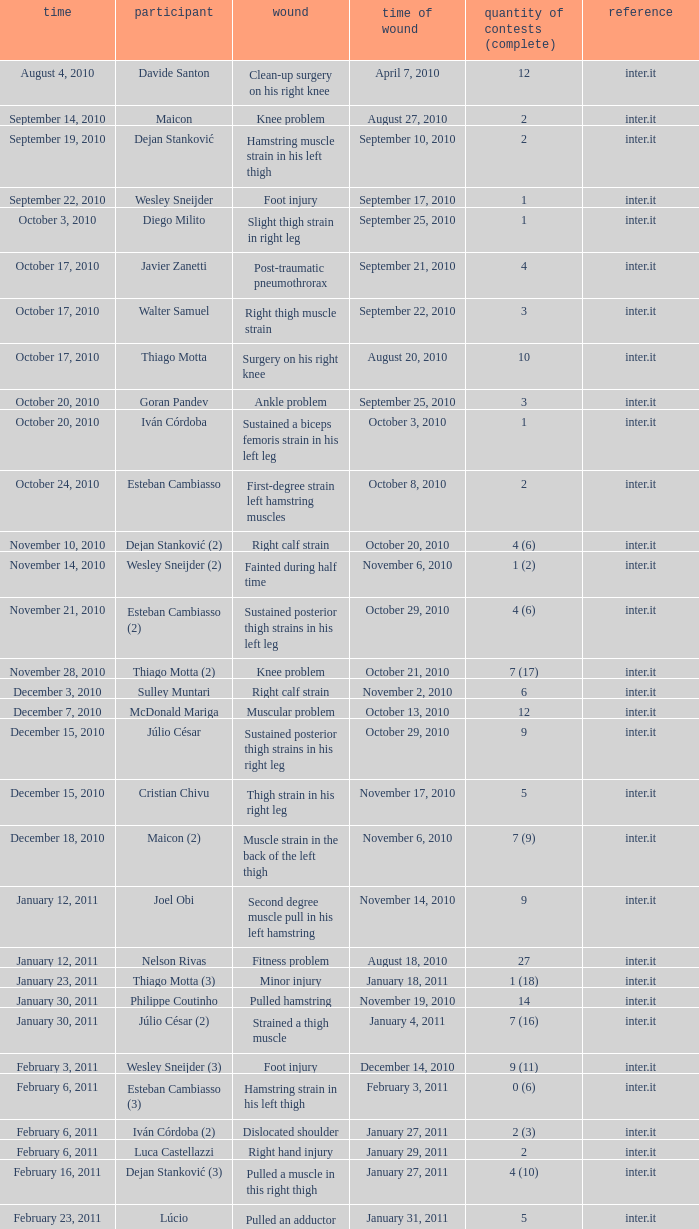Can you parse all the data within this table? {'header': ['time', 'participant', 'wound', 'time of wound', 'quantity of contests (complete)', 'reference'], 'rows': [['August 4, 2010', 'Davide Santon', 'Clean-up surgery on his right knee', 'April 7, 2010', '12', 'inter.it'], ['September 14, 2010', 'Maicon', 'Knee problem', 'August 27, 2010', '2', 'inter.it'], ['September 19, 2010', 'Dejan Stanković', 'Hamstring muscle strain in his left thigh', 'September 10, 2010', '2', 'inter.it'], ['September 22, 2010', 'Wesley Sneijder', 'Foot injury', 'September 17, 2010', '1', 'inter.it'], ['October 3, 2010', 'Diego Milito', 'Slight thigh strain in right leg', 'September 25, 2010', '1', 'inter.it'], ['October 17, 2010', 'Javier Zanetti', 'Post-traumatic pneumothrorax', 'September 21, 2010', '4', 'inter.it'], ['October 17, 2010', 'Walter Samuel', 'Right thigh muscle strain', 'September 22, 2010', '3', 'inter.it'], ['October 17, 2010', 'Thiago Motta', 'Surgery on his right knee', 'August 20, 2010', '10', 'inter.it'], ['October 20, 2010', 'Goran Pandev', 'Ankle problem', 'September 25, 2010', '3', 'inter.it'], ['October 20, 2010', 'Iván Córdoba', 'Sustained a biceps femoris strain in his left leg', 'October 3, 2010', '1', 'inter.it'], ['October 24, 2010', 'Esteban Cambiasso', 'First-degree strain left hamstring muscles', 'October 8, 2010', '2', 'inter.it'], ['November 10, 2010', 'Dejan Stanković (2)', 'Right calf strain', 'October 20, 2010', '4 (6)', 'inter.it'], ['November 14, 2010', 'Wesley Sneijder (2)', 'Fainted during half time', 'November 6, 2010', '1 (2)', 'inter.it'], ['November 21, 2010', 'Esteban Cambiasso (2)', 'Sustained posterior thigh strains in his left leg', 'October 29, 2010', '4 (6)', 'inter.it'], ['November 28, 2010', 'Thiago Motta (2)', 'Knee problem', 'October 21, 2010', '7 (17)', 'inter.it'], ['December 3, 2010', 'Sulley Muntari', 'Right calf strain', 'November 2, 2010', '6', 'inter.it'], ['December 7, 2010', 'McDonald Mariga', 'Muscular problem', 'October 13, 2010', '12', 'inter.it'], ['December 15, 2010', 'Júlio César', 'Sustained posterior thigh strains in his right leg', 'October 29, 2010', '9', 'inter.it'], ['December 15, 2010', 'Cristian Chivu', 'Thigh strain in his right leg', 'November 17, 2010', '5', 'inter.it'], ['December 18, 2010', 'Maicon (2)', 'Muscle strain in the back of the left thigh', 'November 6, 2010', '7 (9)', 'inter.it'], ['January 12, 2011', 'Joel Obi', 'Second degree muscle pull in his left hamstring', 'November 14, 2010', '9', 'inter.it'], ['January 12, 2011', 'Nelson Rivas', 'Fitness problem', 'August 18, 2010', '27', 'inter.it'], ['January 23, 2011', 'Thiago Motta (3)', 'Minor injury', 'January 18, 2011', '1 (18)', 'inter.it'], ['January 30, 2011', 'Philippe Coutinho', 'Pulled hamstring', 'November 19, 2010', '14', 'inter.it'], ['January 30, 2011', 'Júlio César (2)', 'Strained a thigh muscle', 'January 4, 2011', '7 (16)', 'inter.it'], ['February 3, 2011', 'Wesley Sneijder (3)', 'Foot injury', 'December 14, 2010', '9 (11)', 'inter.it'], ['February 6, 2011', 'Esteban Cambiasso (3)', 'Hamstring strain in his left thigh', 'February 3, 2011', '0 (6)', 'inter.it'], ['February 6, 2011', 'Iván Córdoba (2)', 'Dislocated shoulder', 'January 27, 2011', '2 (3)', 'inter.it'], ['February 6, 2011', 'Luca Castellazzi', 'Right hand injury', 'January 29, 2011', '2', 'inter.it'], ['February 16, 2011', 'Dejan Stanković (3)', 'Pulled a muscle in this right thigh', 'January 27, 2011', '4 (10)', 'inter.it'], ['February 23, 2011', 'Lúcio', 'Pulled an adductor muscle in his right thigh', 'January 31, 2011', '5', 'inter.it']]} What is the date of injury when the injury is sustained posterior thigh strains in his left leg? October 29, 2010. 